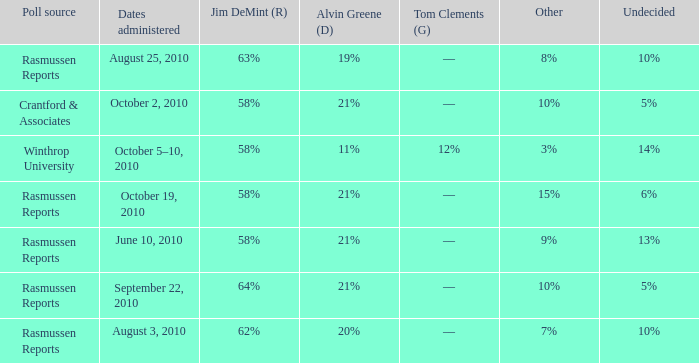Help me parse the entirety of this table. {'header': ['Poll source', 'Dates administered', 'Jim DeMint (R)', 'Alvin Greene (D)', 'Tom Clements (G)', 'Other', 'Undecided'], 'rows': [['Rasmussen Reports', 'August 25, 2010', '63%', '19%', '––', '8%', '10%'], ['Crantford & Associates', 'October 2, 2010', '58%', '21%', '––', '10%', '5%'], ['Winthrop University', 'October 5–10, 2010', '58%', '11%', '12%', '3%', '14%'], ['Rasmussen Reports', 'October 19, 2010', '58%', '21%', '––', '15%', '6%'], ['Rasmussen Reports', 'June 10, 2010', '58%', '21%', '––', '9%', '13%'], ['Rasmussen Reports', 'September 22, 2010', '64%', '21%', '––', '10%', '5%'], ['Rasmussen Reports', 'August 3, 2010', '62%', '20%', '––', '7%', '10%']]} Which poll source had an other of 15%? Rasmussen Reports. 